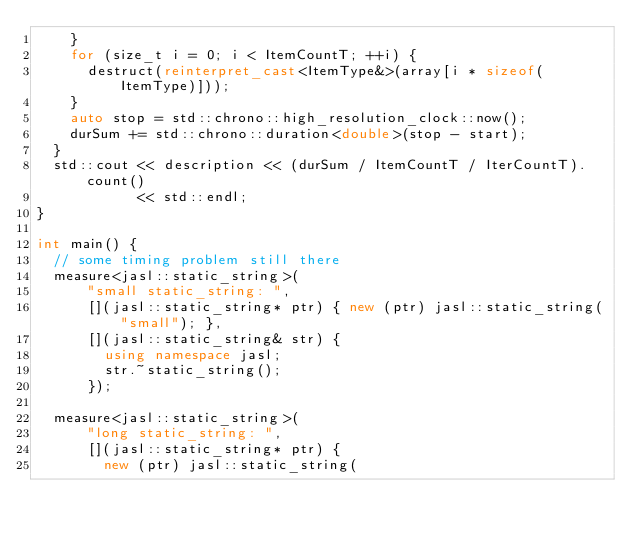Convert code to text. <code><loc_0><loc_0><loc_500><loc_500><_C++_>    }
    for (size_t i = 0; i < ItemCountT; ++i) {
      destruct(reinterpret_cast<ItemType&>(array[i * sizeof(ItemType)]));
    }
    auto stop = std::chrono::high_resolution_clock::now();
    durSum += std::chrono::duration<double>(stop - start);
  }
  std::cout << description << (durSum / ItemCountT / IterCountT).count()
            << std::endl;
}

int main() {
  // some timing problem still there
  measure<jasl::static_string>(
      "small static_string: ",
      [](jasl::static_string* ptr) { new (ptr) jasl::static_string("small"); },
      [](jasl::static_string& str) {
        using namespace jasl;
        str.~static_string();
      });

  measure<jasl::static_string>(
      "long static_string: ",
      [](jasl::static_string* ptr) {
        new (ptr) jasl::static_string(</code> 